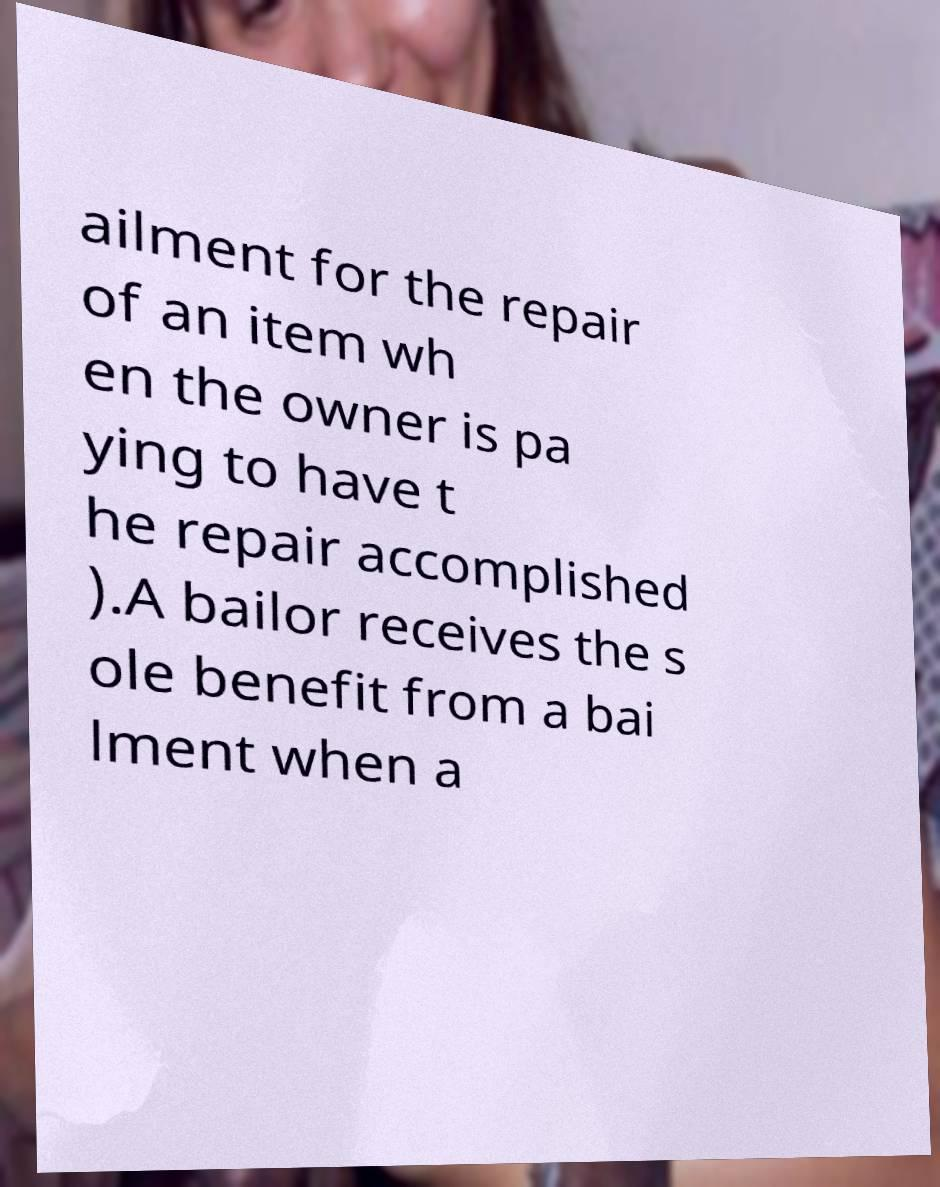Can you accurately transcribe the text from the provided image for me? ailment for the repair of an item wh en the owner is pa ying to have t he repair accomplished ).A bailor receives the s ole benefit from a bai lment when a 